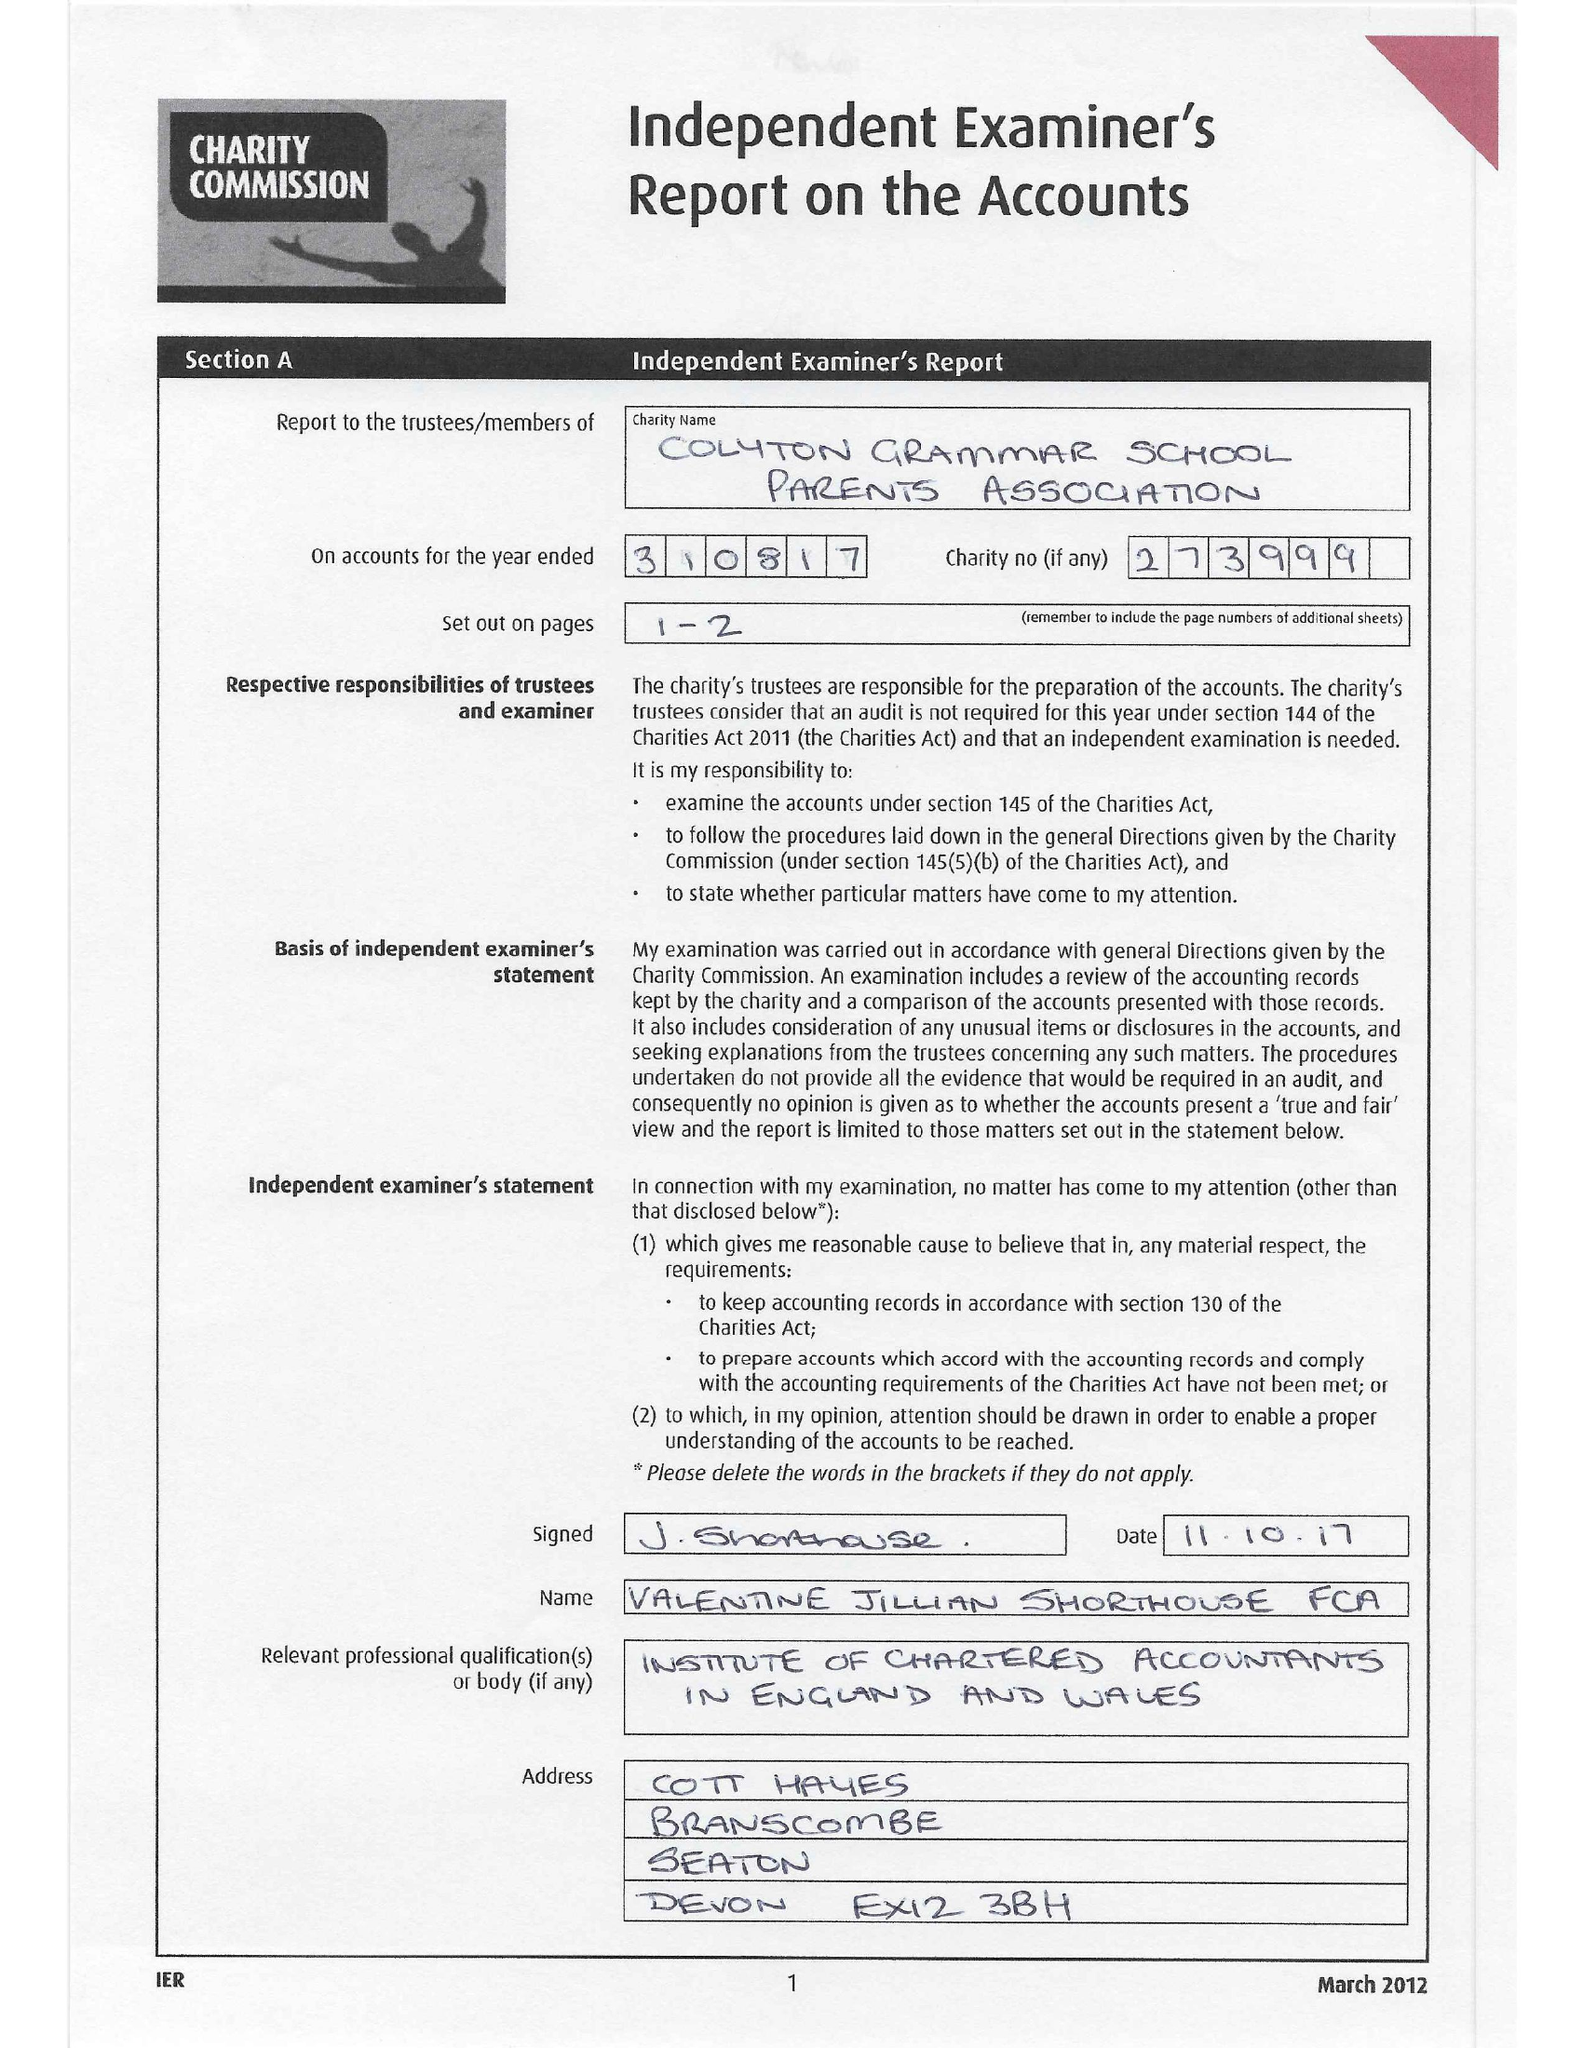What is the value for the address__postcode?
Answer the question using a single word or phrase. EX24 6HN 